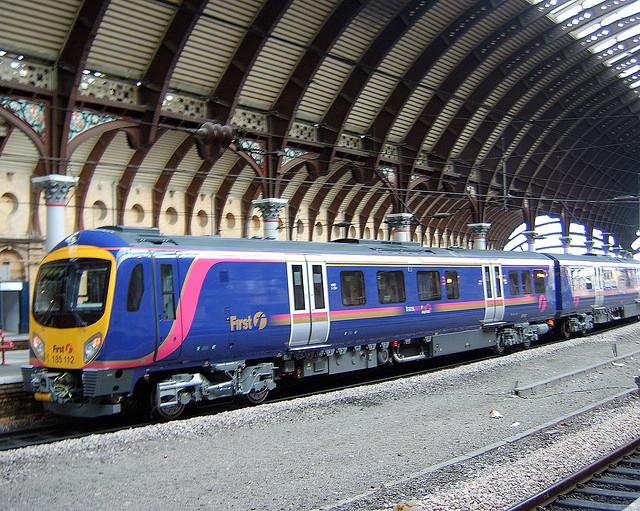Is there a pink stripe on the train?
Write a very short answer. Yes. What is the train on?
Be succinct. Tracks. What is the name on the train?
Give a very brief answer. First. 